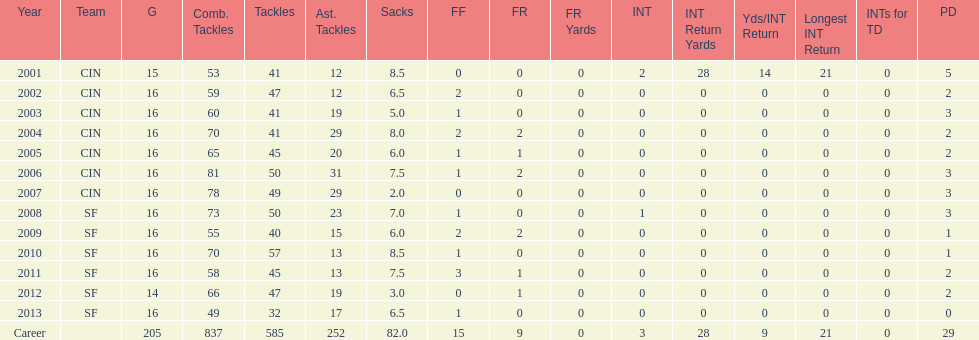How many years did he play in less than 16 games? 2. 